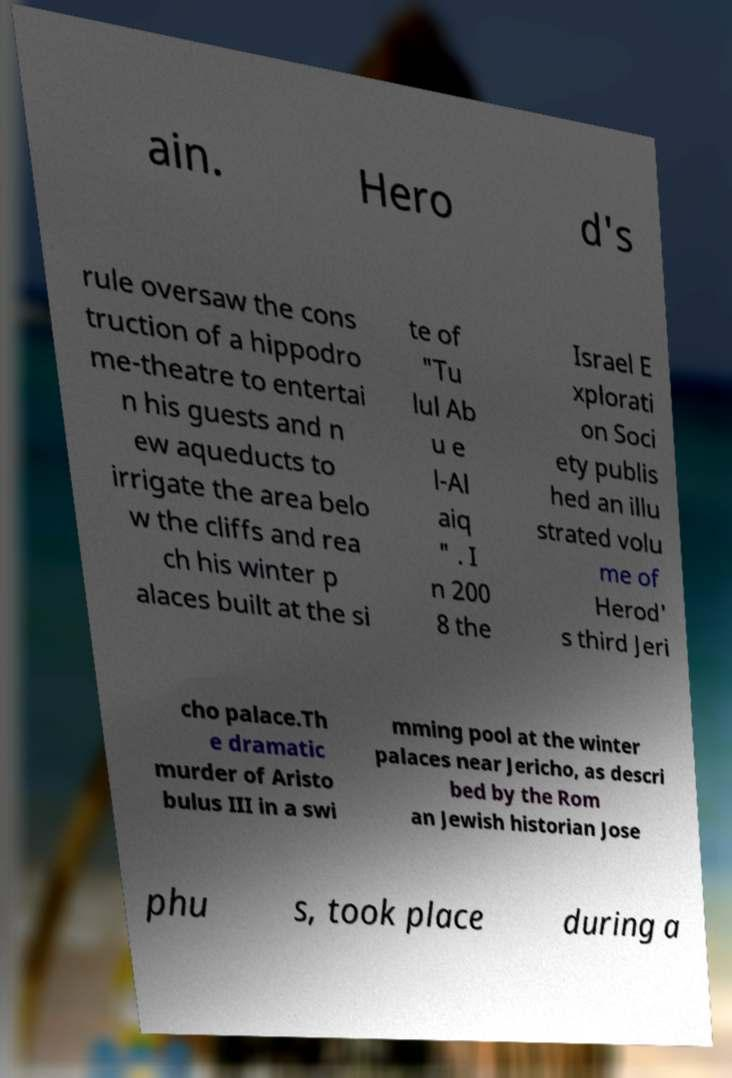Can you read and provide the text displayed in the image?This photo seems to have some interesting text. Can you extract and type it out for me? ain. Hero d's rule oversaw the cons truction of a hippodro me-theatre to entertai n his guests and n ew aqueducts to irrigate the area belo w the cliffs and rea ch his winter p alaces built at the si te of "Tu lul Ab u e l-Al aiq " . I n 200 8 the Israel E xplorati on Soci ety publis hed an illu strated volu me of Herod' s third Jeri cho palace.Th e dramatic murder of Aristo bulus III in a swi mming pool at the winter palaces near Jericho, as descri bed by the Rom an Jewish historian Jose phu s, took place during a 